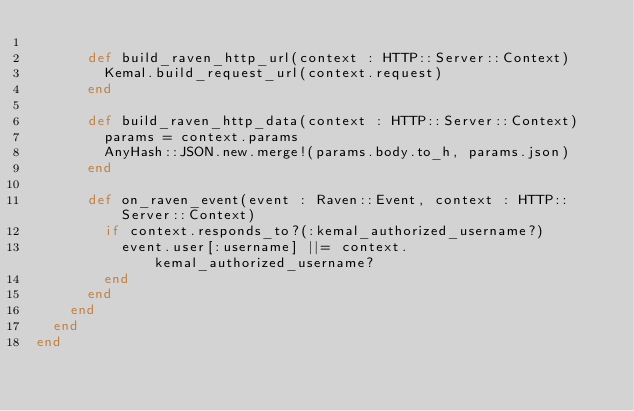<code> <loc_0><loc_0><loc_500><loc_500><_Crystal_>
      def build_raven_http_url(context : HTTP::Server::Context)
        Kemal.build_request_url(context.request)
      end

      def build_raven_http_data(context : HTTP::Server::Context)
        params = context.params
        AnyHash::JSON.new.merge!(params.body.to_h, params.json)
      end

      def on_raven_event(event : Raven::Event, context : HTTP::Server::Context)
        if context.responds_to?(:kemal_authorized_username?)
          event.user[:username] ||= context.kemal_authorized_username?
        end
      end
    end
  end
end
</code> 